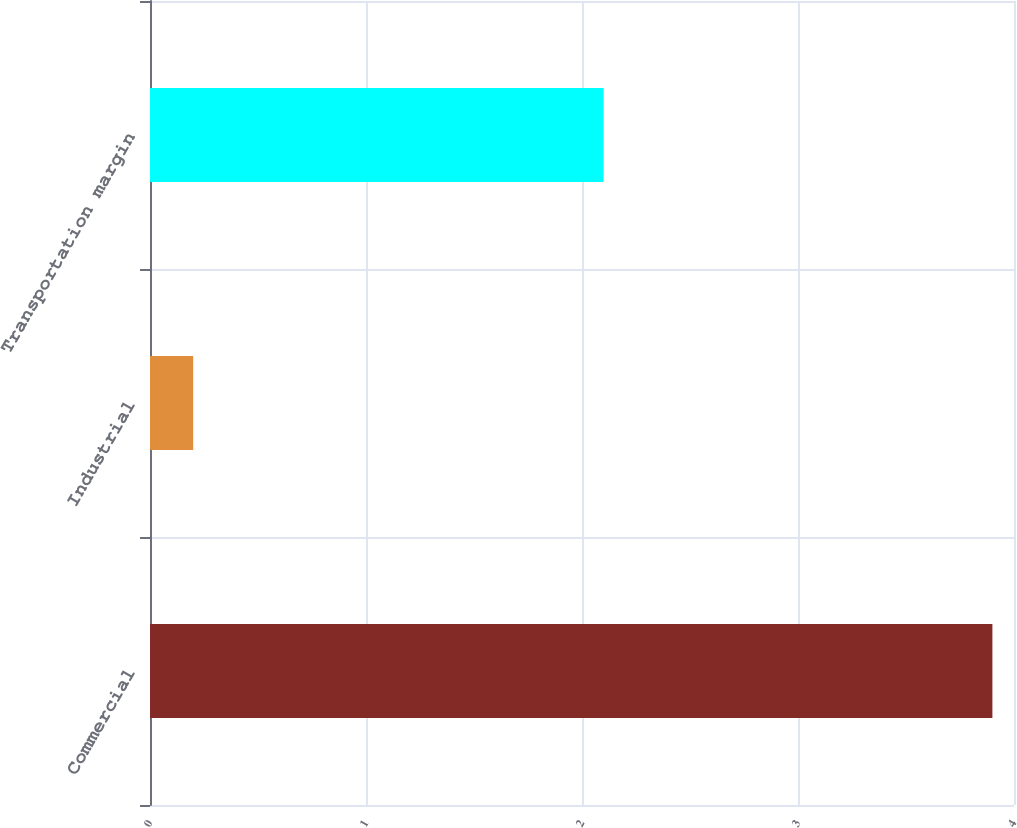<chart> <loc_0><loc_0><loc_500><loc_500><bar_chart><fcel>Commercial<fcel>Industrial<fcel>Transportation margin<nl><fcel>3.9<fcel>0.2<fcel>2.1<nl></chart> 